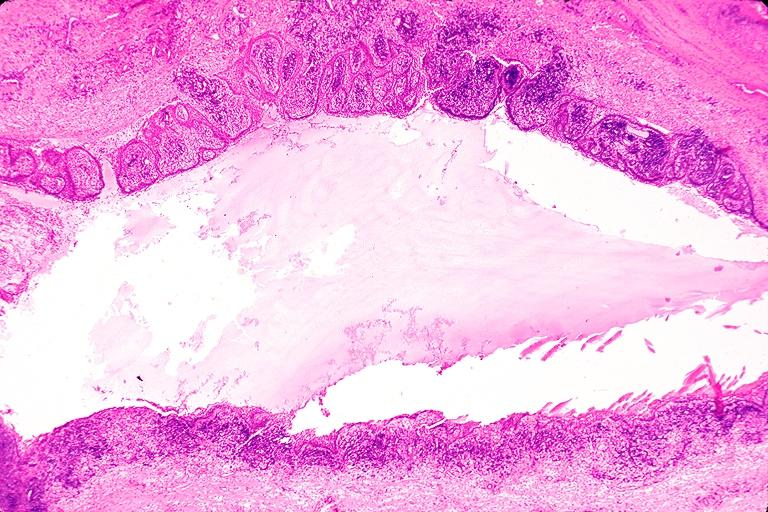where is this?
Answer the question using a single word or phrase. Oral 